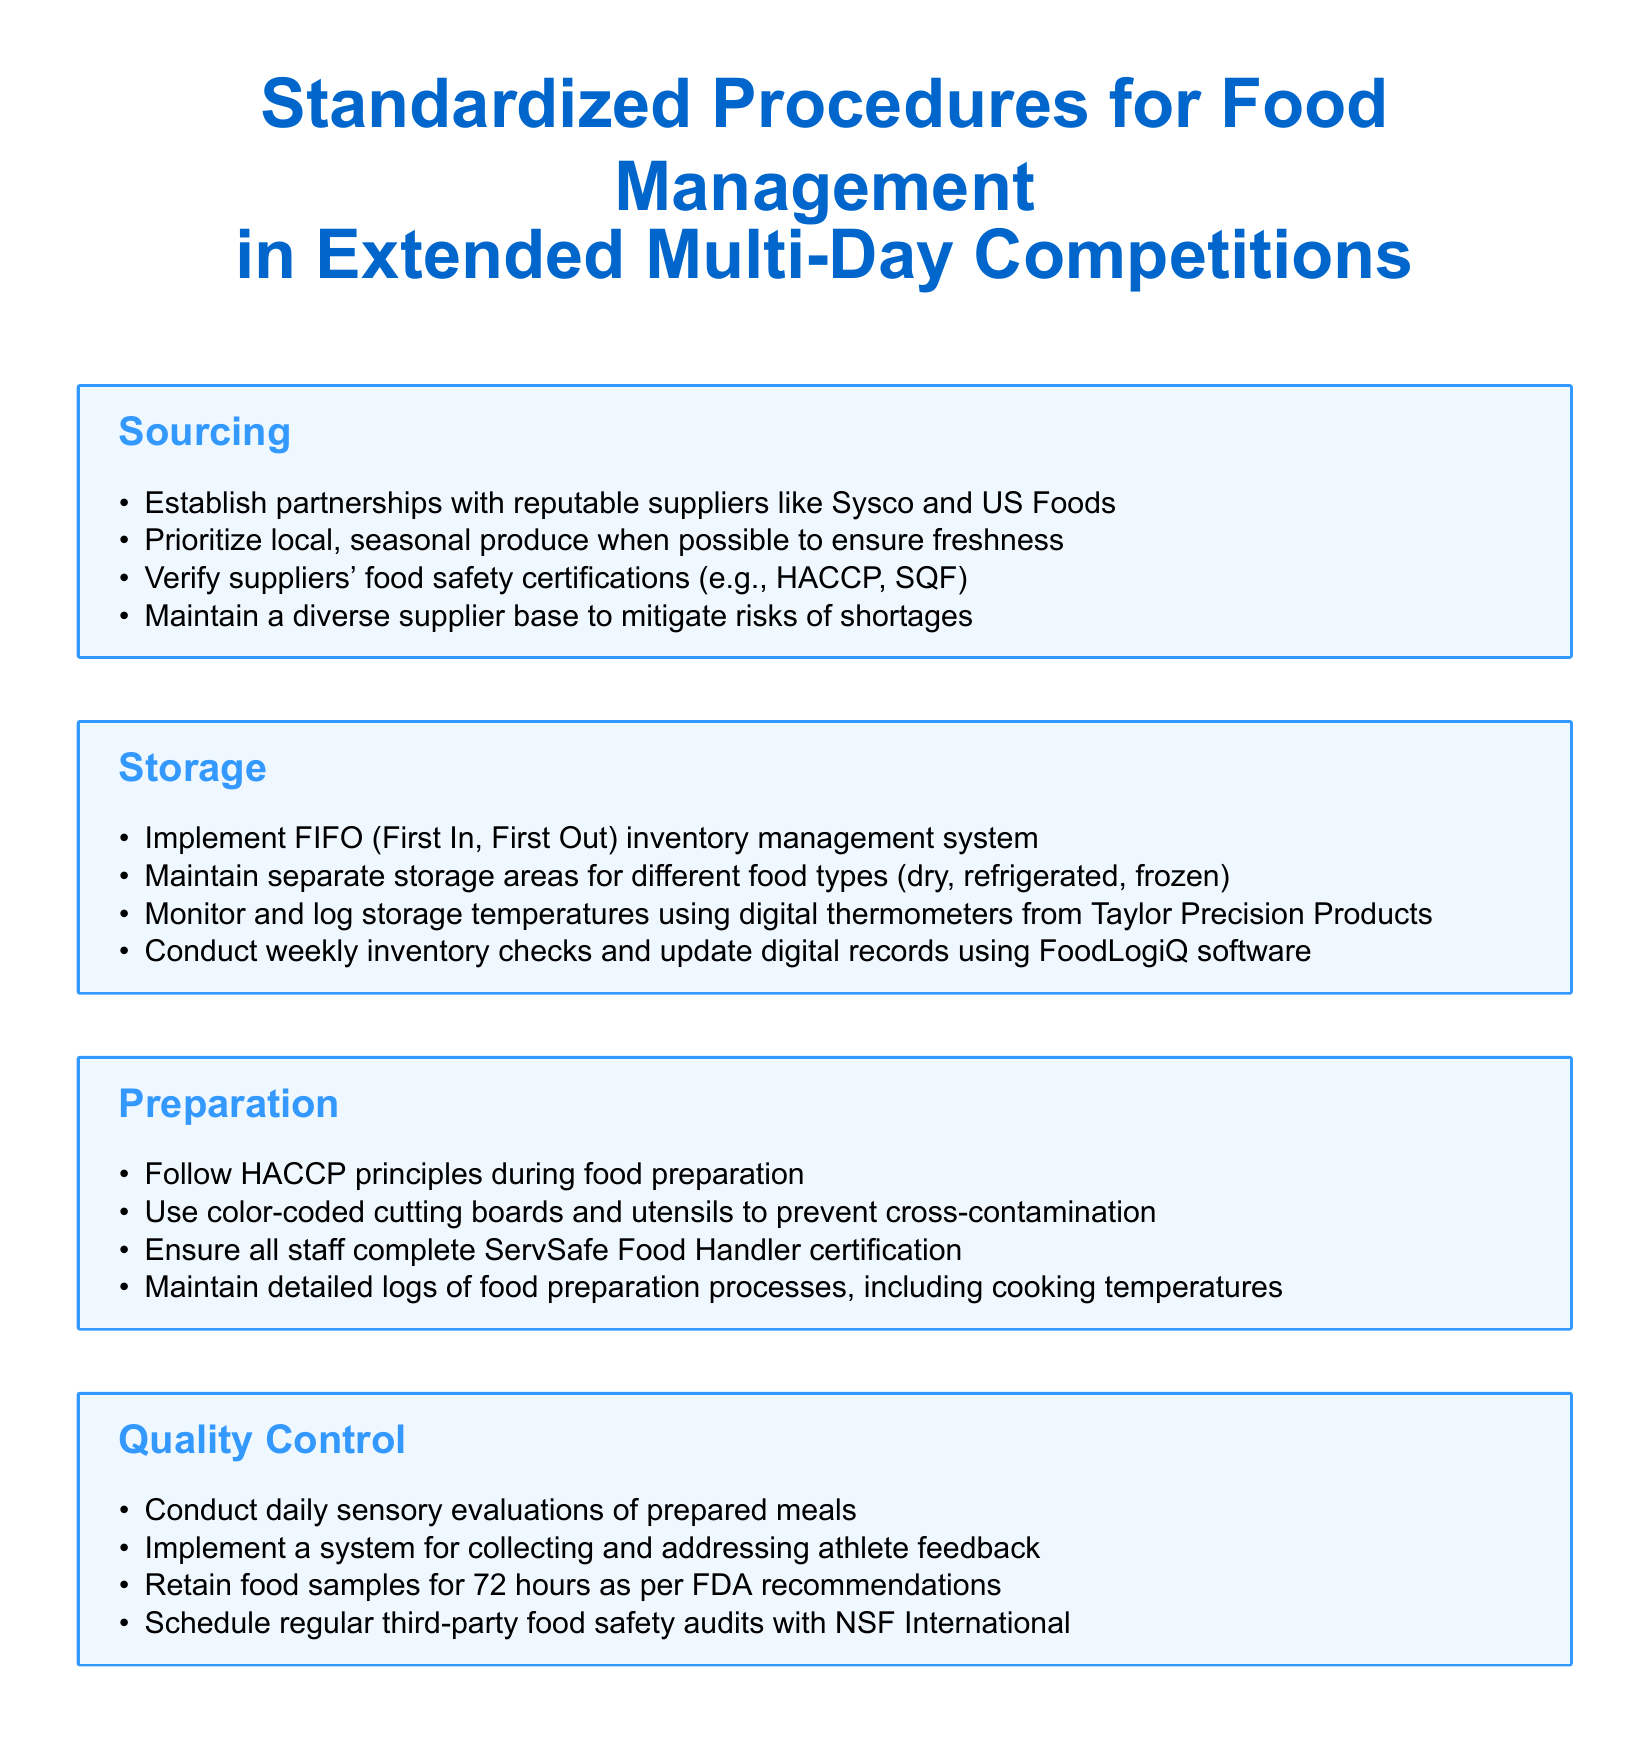What is the first step in sourcing food supplies? The first step involves establishing partnerships with reputable suppliers.
Answer: Establish partnerships with reputable suppliers What safety certifications should suppliers verify? The document mentions HACCP and SQF as necessary certifications.
Answer: HACCP, SQF What inventory management system is recommended for storage? FIFO (First In, First Out) is specified as the recommended system.
Answer: FIFO What type of boards and utensils should be used for food preparation? The document states that color-coded cutting boards and utensils should be used.
Answer: Color-coded cutting boards and utensils How long should food samples be retained according to FDA recommendations? The document specifies a retention period of 72 hours.
Answer: 72 hours What is the purpose of conducting daily sensory evaluations? Daily sensory evaluations are meant to assess the quality of prepared meals.
Answer: Assess quality of prepared meals Who should complete the ServSafe Food Handler certification? All staff involved in food preparation are required to complete this certification.
Answer: All staff What should be done with athlete feedback? The document mentions implementing a system for collecting and addressing athlete feedback.
Answer: Collecting and addressing athlete feedback What entity conducts regular third-party food safety audits? NSF International is mentioned as the auditing organization.
Answer: NSF International 